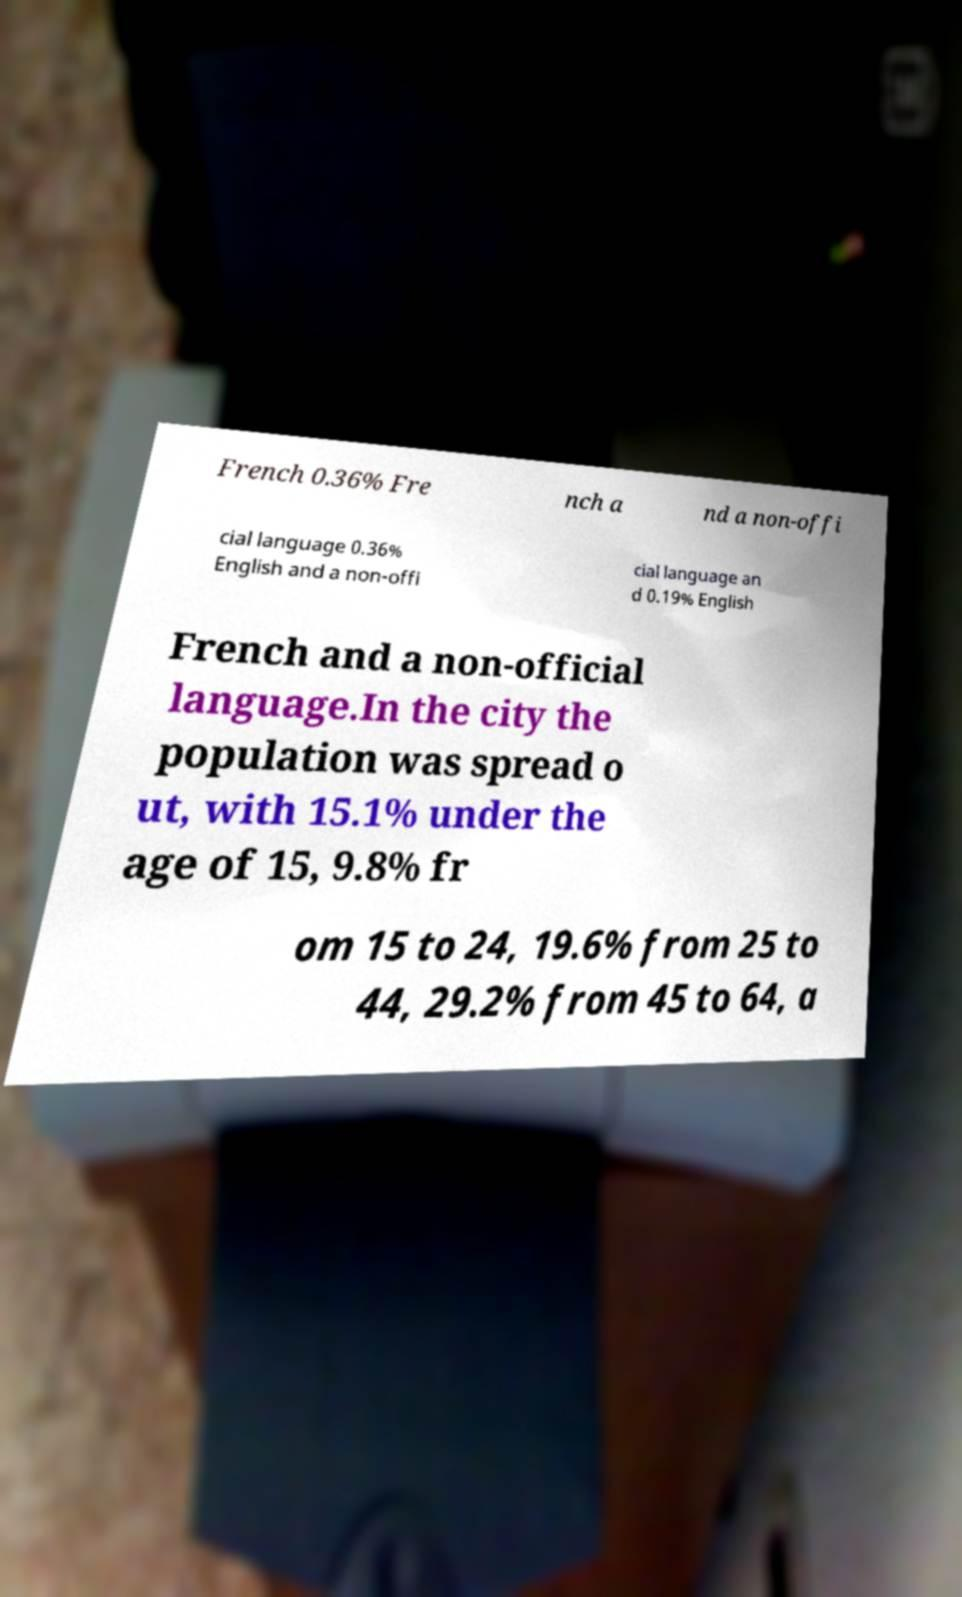What messages or text are displayed in this image? I need them in a readable, typed format. French 0.36% Fre nch a nd a non-offi cial language 0.36% English and a non-offi cial language an d 0.19% English French and a non-official language.In the city the population was spread o ut, with 15.1% under the age of 15, 9.8% fr om 15 to 24, 19.6% from 25 to 44, 29.2% from 45 to 64, a 